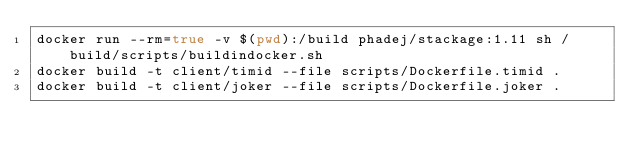<code> <loc_0><loc_0><loc_500><loc_500><_Bash_>docker run --rm=true -v $(pwd):/build phadej/stackage:1.11 sh /build/scripts/buildindocker.sh
docker build -t client/timid --file scripts/Dockerfile.timid .
docker build -t client/joker --file scripts/Dockerfile.joker .</code> 